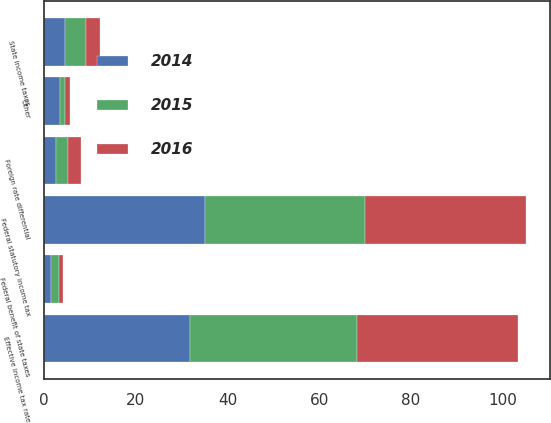<chart> <loc_0><loc_0><loc_500><loc_500><stacked_bar_chart><ecel><fcel>Federal statutory income tax<fcel>State income taxes<fcel>Federal benefit of state taxes<fcel>Foreign rate differential<fcel>Other<fcel>Effective income tax rate<nl><fcel>2016<fcel>35<fcel>3<fcel>1<fcel>3<fcel>1<fcel>35<nl><fcel>2015<fcel>35<fcel>4.6<fcel>1.6<fcel>2.6<fcel>1.1<fcel>36.5<nl><fcel>2014<fcel>35<fcel>4.6<fcel>1.6<fcel>2.6<fcel>3.6<fcel>31.8<nl></chart> 